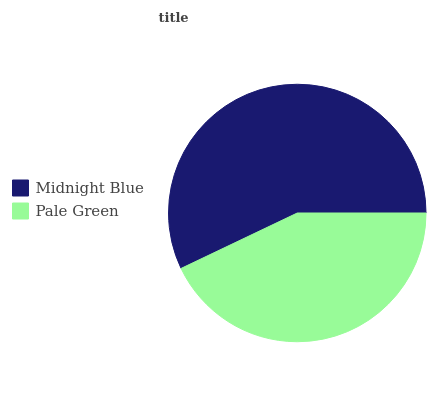Is Pale Green the minimum?
Answer yes or no. Yes. Is Midnight Blue the maximum?
Answer yes or no. Yes. Is Pale Green the maximum?
Answer yes or no. No. Is Midnight Blue greater than Pale Green?
Answer yes or no. Yes. Is Pale Green less than Midnight Blue?
Answer yes or no. Yes. Is Pale Green greater than Midnight Blue?
Answer yes or no. No. Is Midnight Blue less than Pale Green?
Answer yes or no. No. Is Midnight Blue the high median?
Answer yes or no. Yes. Is Pale Green the low median?
Answer yes or no. Yes. Is Pale Green the high median?
Answer yes or no. No. Is Midnight Blue the low median?
Answer yes or no. No. 